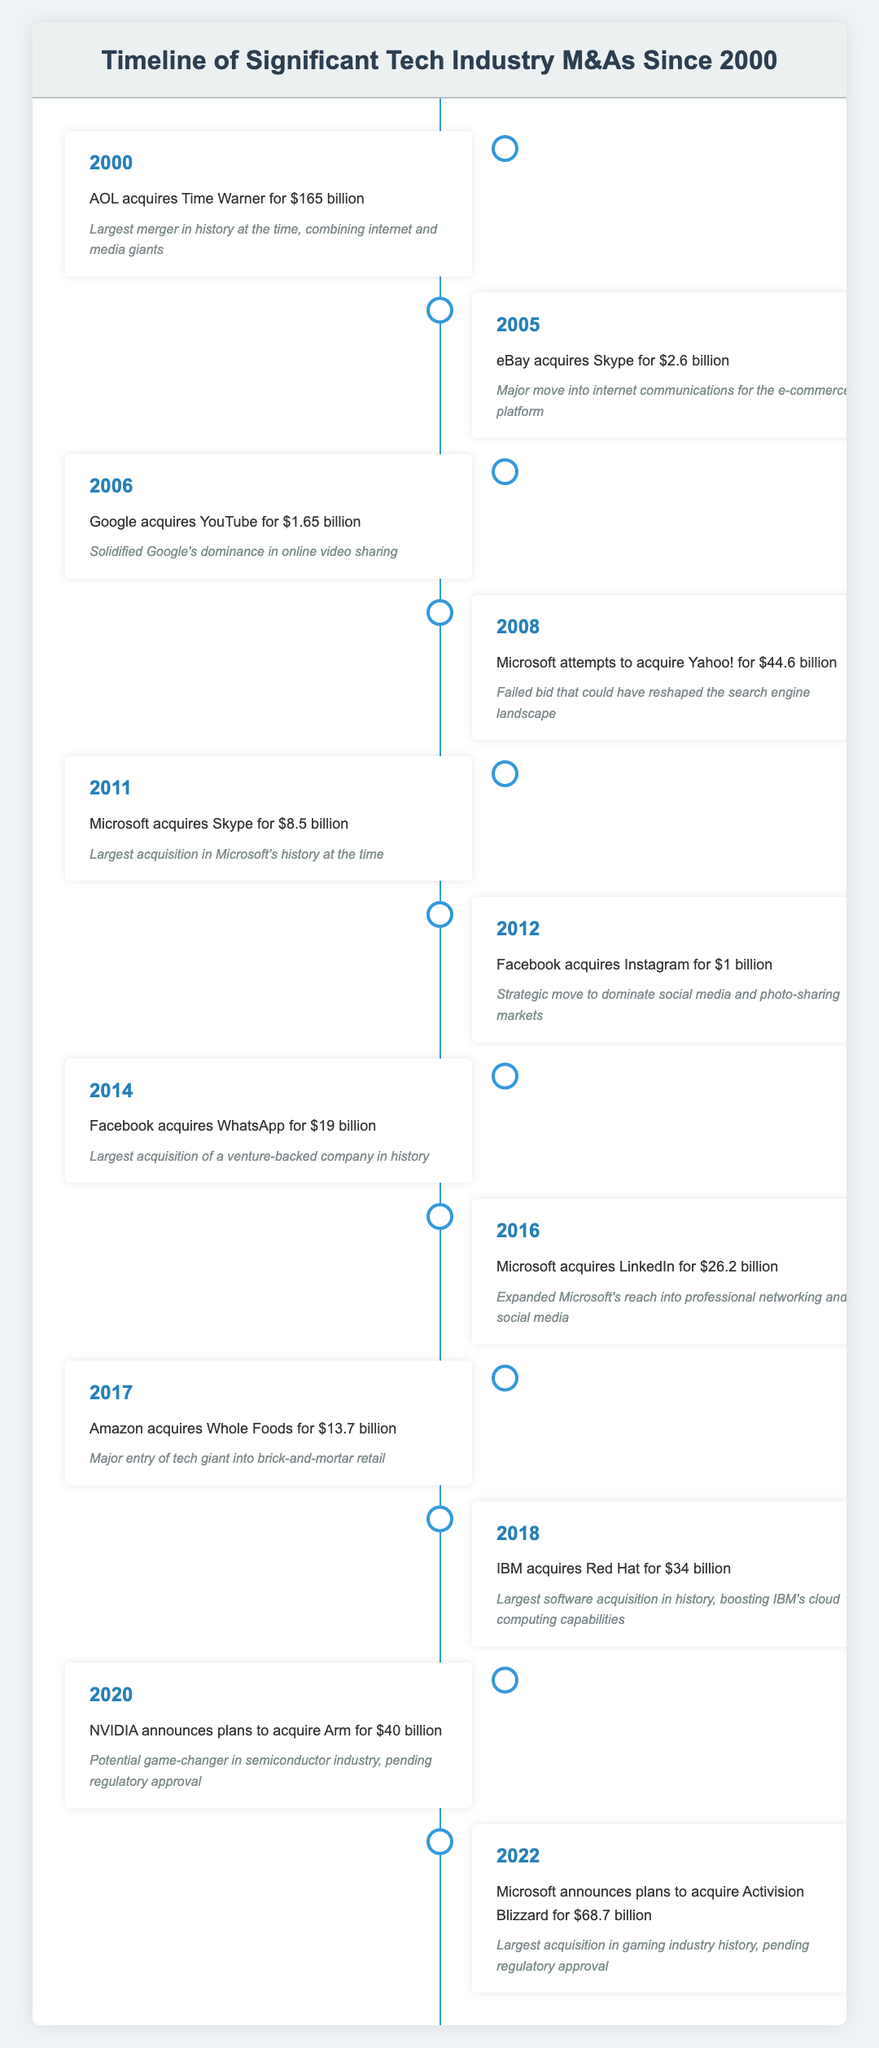What year did AOL acquire Time Warner? The table shows that AOL acquired Time Warner in the year 2000.
Answer: 2000 How much did Facebook pay to acquire Instagram? According to the table, Facebook acquired Instagram for $1 billion in 2012.
Answer: $1 billion Was Microsoft's bid to acquire Yahoo! successful? The table states that Microsoft's attempt to acquire Yahoo! was a failed bid in 2008.
Answer: No What is the total cost of acquisitions by Facebook listed in the table? Facebook acquired Instagram for $1 billion in 2012 and WhatsApp for $19 billion in 2014. Summing these amounts gives us 1 + 19 = 20 billion.
Answer: $20 billion In what year did IBM acquire Red Hat, and how much did they spend? The table indicates that IBM acquired Red Hat in 2018 for $34 billion.
Answer: 2018, $34 billion Which acquisition listed is the largest in the tech industry and what is its value? The table states that AOL acquired Time Warner for $165 billion in 2000, making it the largest acquisition listed.
Answer: $165 billion Which company was involved in acquiring a grocery chain, and what was the acquisition amount? According to the table, Amazon acquired Whole Foods for $13.7 billion in 2017.
Answer: Amazon, $13.7 billion Is the acquisition of LinkedIn by Microsoft more recent than the acquisition of Skype? The table indicates that Microsoft acquired Skype in 2011 and LinkedIn in 2016, confirming LinkedIn's acquisition is more recent.
Answer: Yes What was the average amount spent on acquisitions by Microsoft according to the listed events? Microsoft acquired Skype for $8.5 billion in 2011 and attempted to acquire Yahoo! for $44.6 billion in 2008. The average is calculated by summing these amounts (8.5 + 44.6) and dividing by 2, which gives (53.1 / 2 = 26.55 billion).
Answer: $26.55 billion 